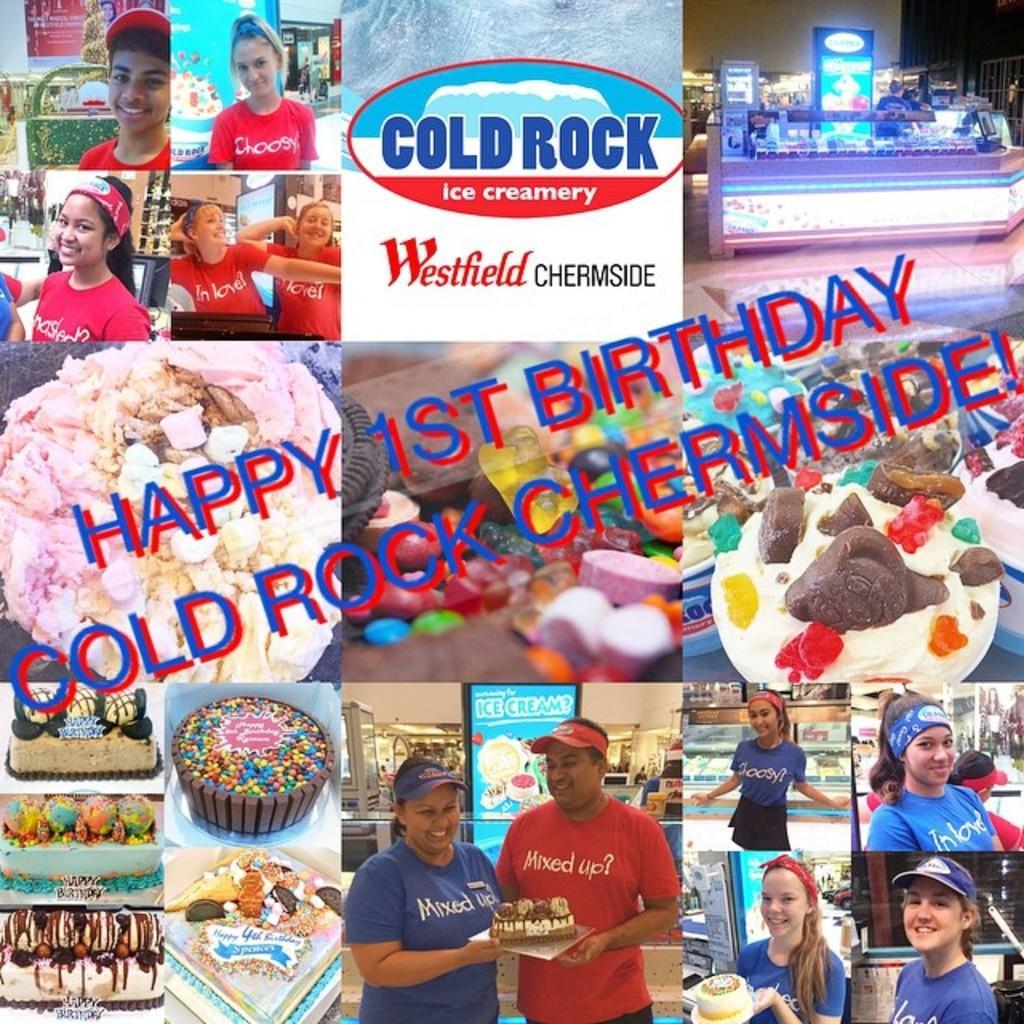In one or two sentences, can you explain what this image depicts? In this image I can see a group of people are standing in a bakery and holding cakes in their hand. At the top I can see a log, table and a wall. This image is taken may be in a bakery. 